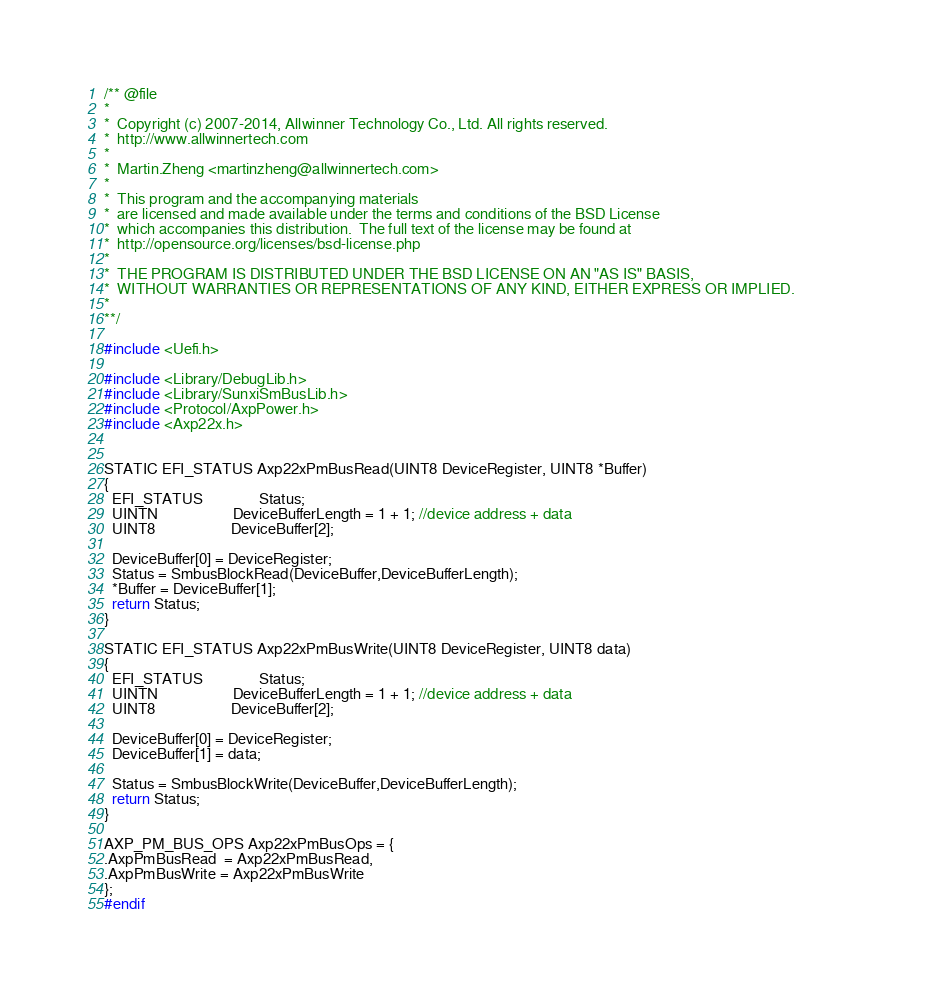Convert code to text. <code><loc_0><loc_0><loc_500><loc_500><_C_>/** @file
*
*  Copyright (c) 2007-2014, Allwinner Technology Co., Ltd. All rights reserved.
*  http://www.allwinnertech.com
*
*  Martin.Zheng <martinzheng@allwinnertech.com>
*  
*  This program and the accompanying materials                          
*  are licensed and made available under the terms and conditions of the BSD License         
*  which accompanies this distribution.  The full text of the license may be found at        
*  http://opensource.org/licenses/bsd-license.php                                            
*
*  THE PROGRAM IS DISTRIBUTED UNDER THE BSD LICENSE ON AN "AS IS" BASIS,                     
*  WITHOUT WARRANTIES OR REPRESENTATIONS OF ANY KIND, EITHER EXPRESS OR IMPLIED.             
*
**/

#include <Uefi.h>

#include <Library/DebugLib.h>
#include <Library/SunxiSmBusLib.h>
#include <Protocol/AxpPower.h>
#include <Axp22x.h>


STATIC EFI_STATUS Axp22xPmBusRead(UINT8 DeviceRegister, UINT8 *Buffer)
{
  EFI_STATUS               Status;
  UINTN                    DeviceBufferLength = 1 + 1; //device address + data
  UINT8                    DeviceBuffer[2];

  DeviceBuffer[0] = DeviceRegister;
  Status = SmbusBlockRead(DeviceBuffer,DeviceBufferLength);
  *Buffer = DeviceBuffer[1];
  return Status;
}

STATIC EFI_STATUS Axp22xPmBusWrite(UINT8 DeviceRegister, UINT8 data)
{
  EFI_STATUS               Status;
  UINTN                    DeviceBufferLength = 1 + 1; //device address + data
  UINT8                    DeviceBuffer[2];

  DeviceBuffer[0] = DeviceRegister;
  DeviceBuffer[1] = data;

  Status = SmbusBlockWrite(DeviceBuffer,DeviceBufferLength);
  return Status;
}

AXP_PM_BUS_OPS Axp22xPmBusOps = {
.AxpPmBusRead  = Axp22xPmBusRead,
.AxpPmBusWrite = Axp22xPmBusWrite
};
#endif
</code> 